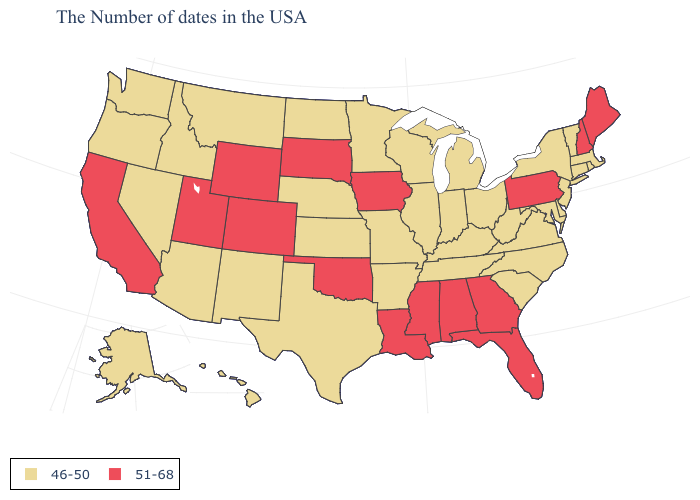Does West Virginia have the lowest value in the USA?
Answer briefly. Yes. Does Iowa have the highest value in the MidWest?
Concise answer only. Yes. Does Oklahoma have the lowest value in the South?
Give a very brief answer. No. Does the map have missing data?
Concise answer only. No. What is the highest value in the USA?
Keep it brief. 51-68. Name the states that have a value in the range 46-50?
Give a very brief answer. Massachusetts, Rhode Island, Vermont, Connecticut, New York, New Jersey, Delaware, Maryland, Virginia, North Carolina, South Carolina, West Virginia, Ohio, Michigan, Kentucky, Indiana, Tennessee, Wisconsin, Illinois, Missouri, Arkansas, Minnesota, Kansas, Nebraska, Texas, North Dakota, New Mexico, Montana, Arizona, Idaho, Nevada, Washington, Oregon, Alaska, Hawaii. What is the value of Missouri?
Give a very brief answer. 46-50. What is the value of Ohio?
Concise answer only. 46-50. What is the highest value in states that border Oregon?
Keep it brief. 51-68. Does the map have missing data?
Write a very short answer. No. Name the states that have a value in the range 46-50?
Quick response, please. Massachusetts, Rhode Island, Vermont, Connecticut, New York, New Jersey, Delaware, Maryland, Virginia, North Carolina, South Carolina, West Virginia, Ohio, Michigan, Kentucky, Indiana, Tennessee, Wisconsin, Illinois, Missouri, Arkansas, Minnesota, Kansas, Nebraska, Texas, North Dakota, New Mexico, Montana, Arizona, Idaho, Nevada, Washington, Oregon, Alaska, Hawaii. Does Florida have the highest value in the USA?
Short answer required. Yes. Is the legend a continuous bar?
Give a very brief answer. No. What is the lowest value in states that border Michigan?
Keep it brief. 46-50. What is the highest value in the MidWest ?
Keep it brief. 51-68. 